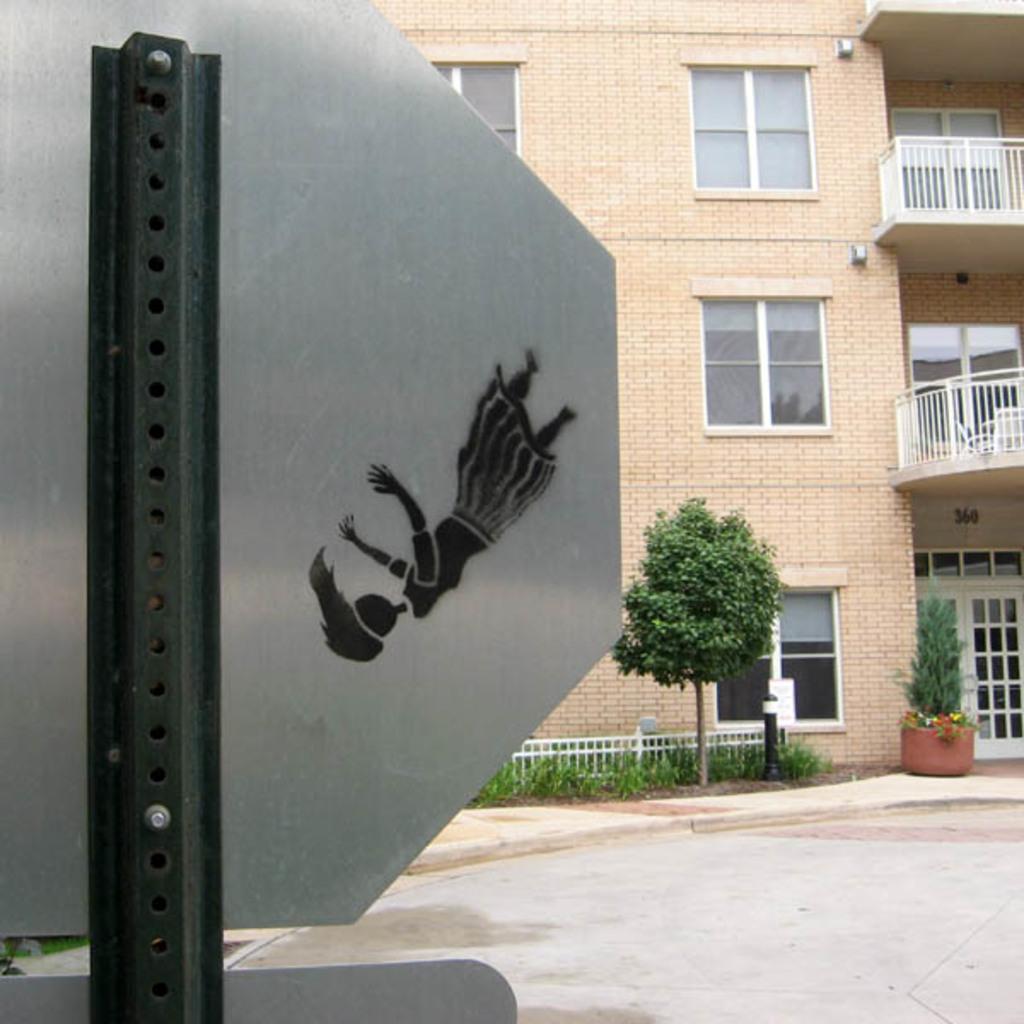Could you give a brief overview of what you see in this image? In this picture we can see the building, we can see tree, board and the side we can see the garden. 